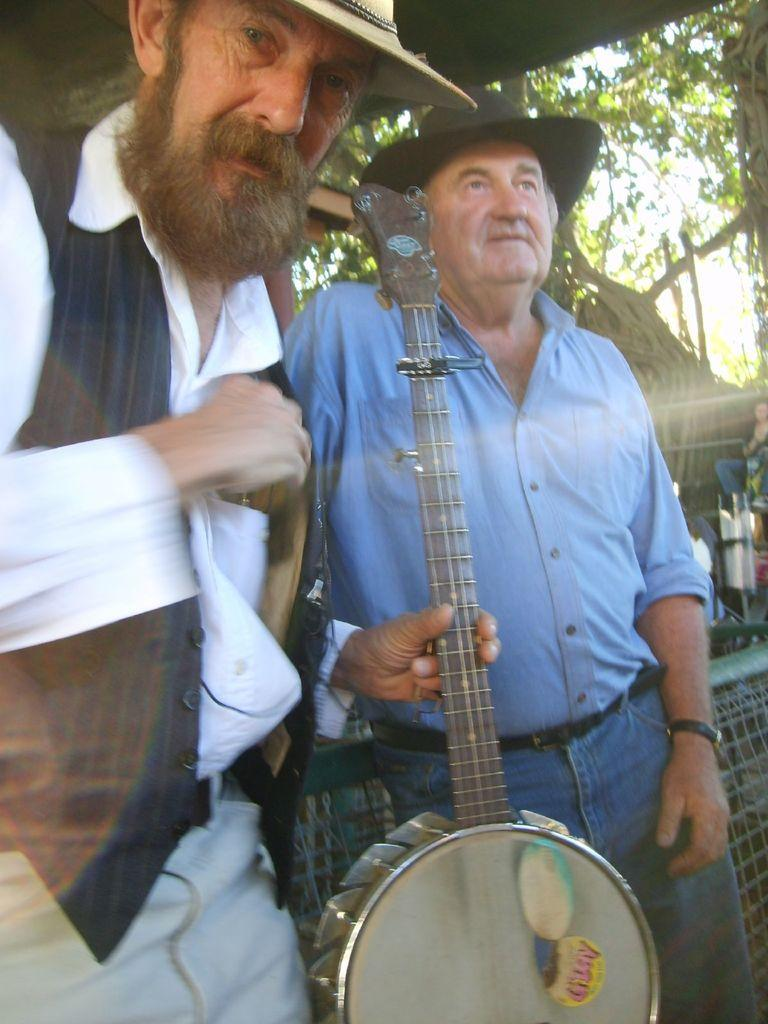How many people are in the image? There are two persons standing in the image. What is one of the persons holding? One person is holding a musical instrument in their hand. What can be seen in the background of the image? There are trees and the sky visible in the background of the image. What type of whip is being used by the person in the image? There is no whip present in the image; the person is holding a musical instrument. 